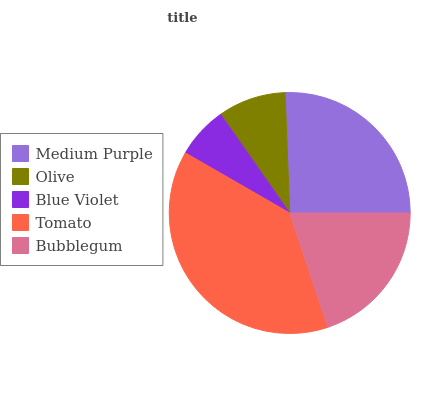Is Blue Violet the minimum?
Answer yes or no. Yes. Is Tomato the maximum?
Answer yes or no. Yes. Is Olive the minimum?
Answer yes or no. No. Is Olive the maximum?
Answer yes or no. No. Is Medium Purple greater than Olive?
Answer yes or no. Yes. Is Olive less than Medium Purple?
Answer yes or no. Yes. Is Olive greater than Medium Purple?
Answer yes or no. No. Is Medium Purple less than Olive?
Answer yes or no. No. Is Bubblegum the high median?
Answer yes or no. Yes. Is Bubblegum the low median?
Answer yes or no. Yes. Is Medium Purple the high median?
Answer yes or no. No. Is Blue Violet the low median?
Answer yes or no. No. 